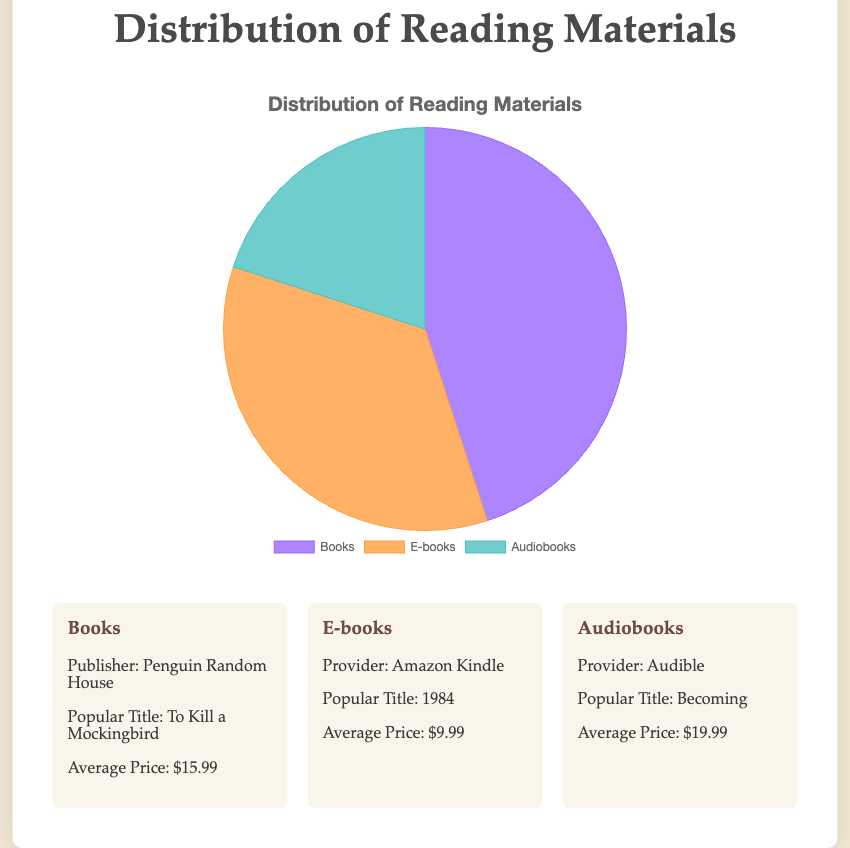Which reading material has the highest distribution percentage? The pie chart shows three categories: Books, E-books, and Audiobooks. The slice representing Books is the largest, indicating the highest percentage.
Answer: Books What is the total distribution percentage for E-books and Audiobooks combined? E-books have a distribution of 35% and Audiobooks have 20%. Adding these percentages together: 35% + 20% = 55%.
Answer: 55% How does the distribution of Books compare to E-books? Books have a distribution of 45%, while E-books have 35%. Books have a higher distribution by 10%.
Answer: Books are higher by 10% Which reading material has the lowest distribution percentage? The pie chart shows that the slice representing Audiobooks is the smallest, indicating the lowest percentage.
Answer: Audiobooks If the distribution percentage of Books increased by 10%, what would the new percentage be? The current distribution of Books is 45%. If it increases by 10%, the new percentage would be 45% + 10% = 55%.
Answer: 55% By how much would the distribution of Audiobooks need to increase to match that of E-books? E-books have a distribution of 35%, while Audiobooks have 20%. The increase needed is 35% - 20% = 15%.
Answer: 15% What percentage of the total distribution do printed materials (Books) constitute? The total distribution is 100%, and the portion for Books is 45%. Therefore, the percentage is 45%.
Answer: 45% Which category is represented by the color orange in the pie chart? The color orange is used for E-books in the pie chart, as indicated by the legend.
Answer: E-books Between Books and Audiobooks, which has a larger distribution and by how much? Books have a distribution of 45%, while Audiobooks have 20%. The difference is 45% - 20% = 25%.
Answer: Books by 25% If the average price of E-books decreased by $2, what would the new average price be? The current average price of E-books is $9.99. Decreasing it by $2, the new average price would be $9.99 - $2 = $7.99.
Answer: $7.99 